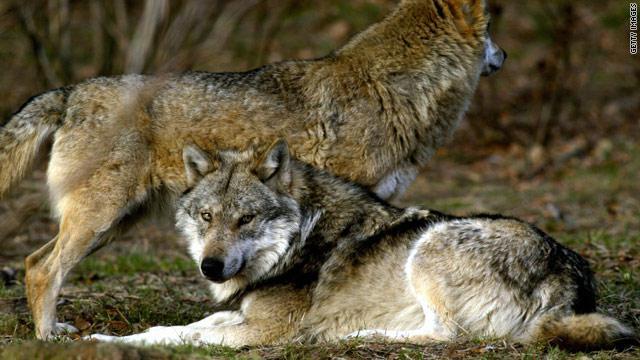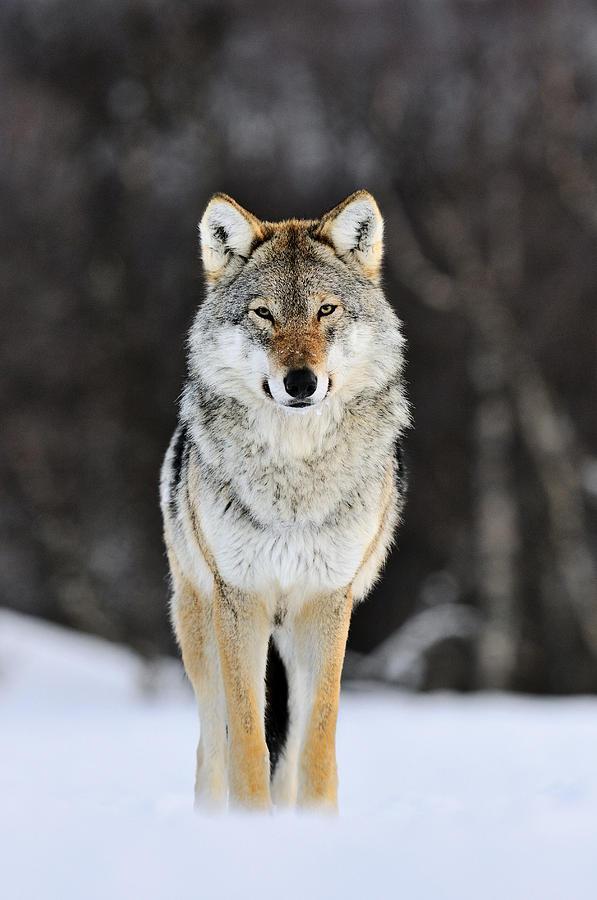The first image is the image on the left, the second image is the image on the right. Considering the images on both sides, is "Three wolves are visible." valid? Answer yes or no. Yes. The first image is the image on the left, the second image is the image on the right. For the images shown, is this caption "The left image contains twice as many wolves as the right image." true? Answer yes or no. Yes. 